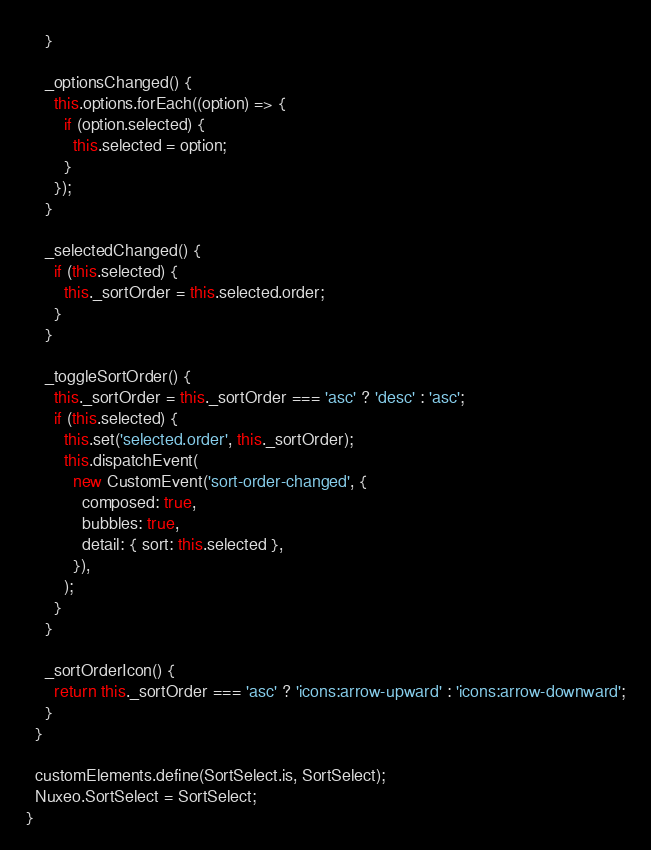<code> <loc_0><loc_0><loc_500><loc_500><_JavaScript_>    }

    _optionsChanged() {
      this.options.forEach((option) => {
        if (option.selected) {
          this.selected = option;
        }
      });
    }

    _selectedChanged() {
      if (this.selected) {
        this._sortOrder = this.selected.order;
      }
    }

    _toggleSortOrder() {
      this._sortOrder = this._sortOrder === 'asc' ? 'desc' : 'asc';
      if (this.selected) {
        this.set('selected.order', this._sortOrder);
        this.dispatchEvent(
          new CustomEvent('sort-order-changed', {
            composed: true,
            bubbles: true,
            detail: { sort: this.selected },
          }),
        );
      }
    }

    _sortOrderIcon() {
      return this._sortOrder === 'asc' ? 'icons:arrow-upward' : 'icons:arrow-downward';
    }
  }

  customElements.define(SortSelect.is, SortSelect);
  Nuxeo.SortSelect = SortSelect;
}
</code> 